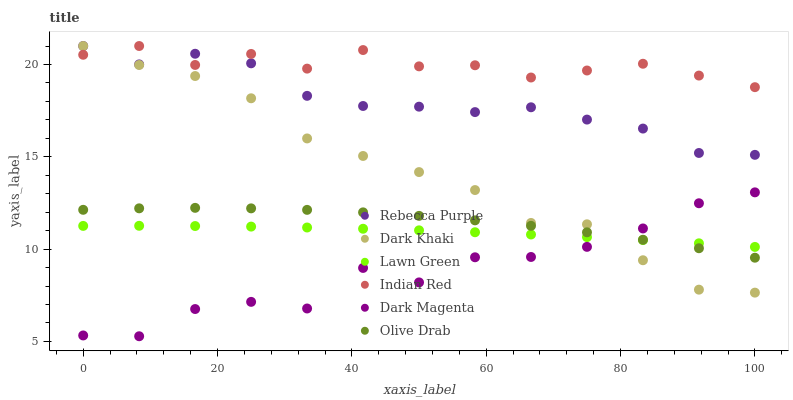Does Dark Magenta have the minimum area under the curve?
Answer yes or no. Yes. Does Indian Red have the maximum area under the curve?
Answer yes or no. Yes. Does Dark Khaki have the minimum area under the curve?
Answer yes or no. No. Does Dark Khaki have the maximum area under the curve?
Answer yes or no. No. Is Lawn Green the smoothest?
Answer yes or no. Yes. Is Dark Magenta the roughest?
Answer yes or no. Yes. Is Dark Khaki the smoothest?
Answer yes or no. No. Is Dark Khaki the roughest?
Answer yes or no. No. Does Dark Magenta have the lowest value?
Answer yes or no. Yes. Does Dark Khaki have the lowest value?
Answer yes or no. No. Does Indian Red have the highest value?
Answer yes or no. Yes. Does Dark Magenta have the highest value?
Answer yes or no. No. Is Dark Magenta less than Rebecca Purple?
Answer yes or no. Yes. Is Indian Red greater than Lawn Green?
Answer yes or no. Yes. Does Indian Red intersect Dark Khaki?
Answer yes or no. Yes. Is Indian Red less than Dark Khaki?
Answer yes or no. No. Is Indian Red greater than Dark Khaki?
Answer yes or no. No. Does Dark Magenta intersect Rebecca Purple?
Answer yes or no. No. 